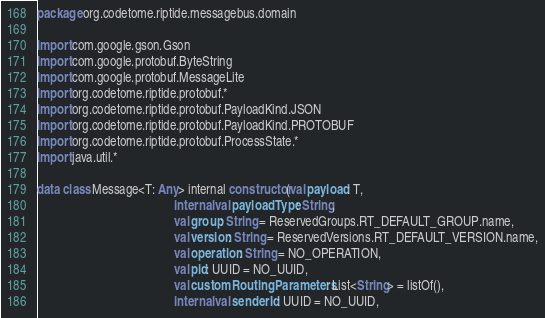Convert code to text. <code><loc_0><loc_0><loc_500><loc_500><_Kotlin_>package org.codetome.riptide.messagebus.domain

import com.google.gson.Gson
import com.google.protobuf.ByteString
import com.google.protobuf.MessageLite
import org.codetome.riptide.protobuf.*
import org.codetome.riptide.protobuf.PayloadKind.JSON
import org.codetome.riptide.protobuf.PayloadKind.PROTOBUF
import org.codetome.riptide.protobuf.ProcessState.*
import java.util.*

data class Message<T: Any> internal constructor(val payload: T,
                                           internal val payloadType: String,
                                           val group: String = ReservedGroups.RT_DEFAULT_GROUP.name,
                                           val version: String = ReservedVersions.RT_DEFAULT_VERSION.name,
                                           val operation: String = NO_OPERATION,
                                           val pid: UUID = NO_UUID,
                                           val customRoutingParameters: List<String> = listOf(),
                                           internal val senderId: UUID = NO_UUID,</code> 